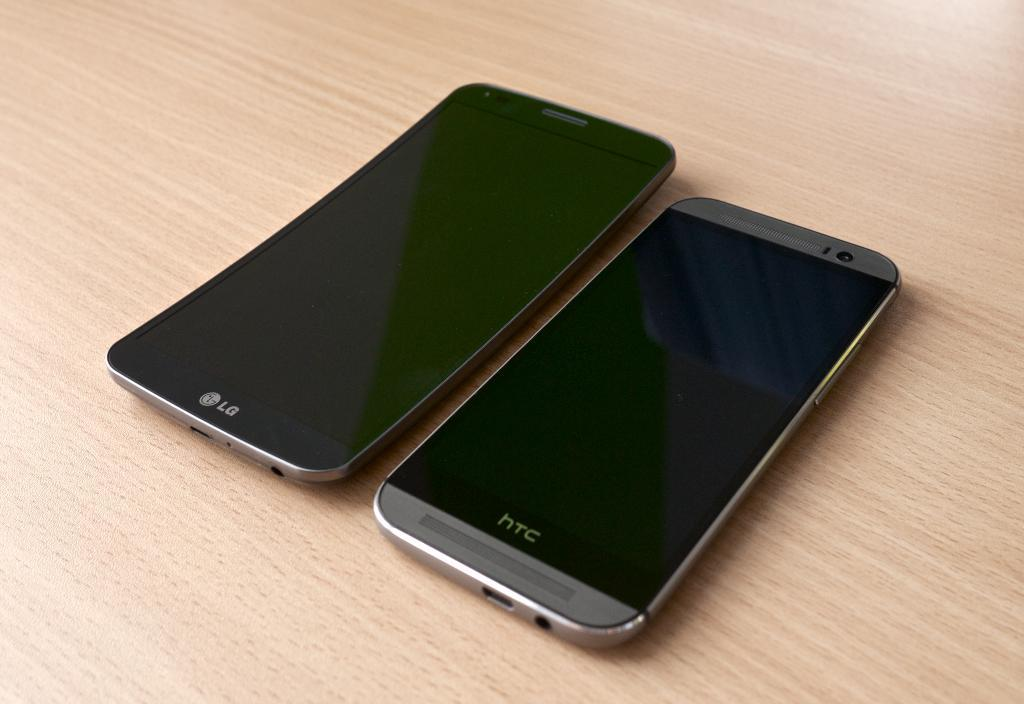<image>
Render a clear and concise summary of the photo. LG and HTC are the brands shown on these two cellphones. 